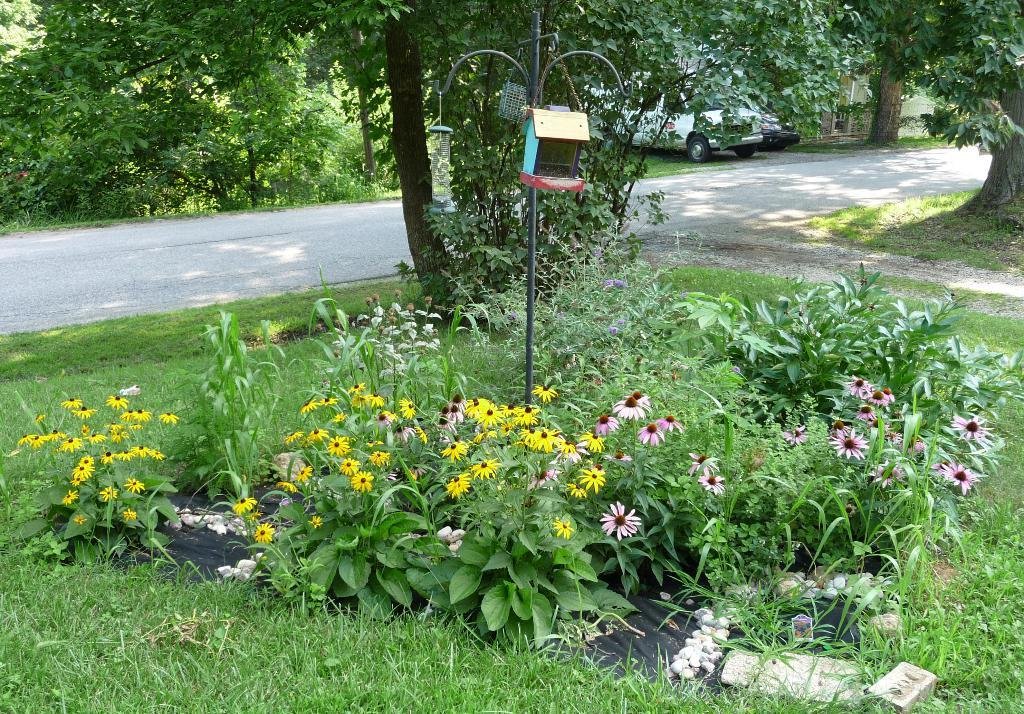What types of vegetation can be seen in the image? There are plants, flowers, and trees visible in the image. What type of ground cover is present in the image? Grass is visible in the image. What is the primary mode of transportation in the image? A vehicle is visible in the image. What type of surface is the vehicle traveling on? A road is present in the image. What object can be seen in the middle of the image? There is a pole visible in the middle of the image. What type of disgust can be seen on the faces of the plants in the image? There are no faces or expressions of disgust present on the plants in the image. What type of air is visible in the image? There is no air visible in the image; it is a static representation of the scene. 